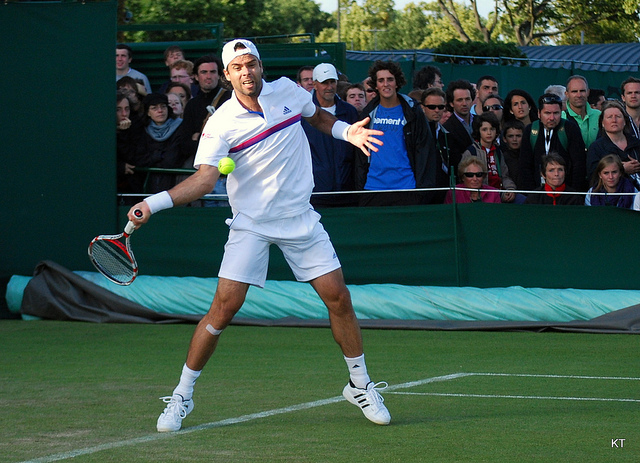<image>What color is the man's pants in the background? I am not sure about the color of the man's pants in the background, it could be black, white, or blue. What color is the man's pants in the background? I am not sure what color is the man's pants in the background. It can be seen 'blue', 'black' or 'white'. 